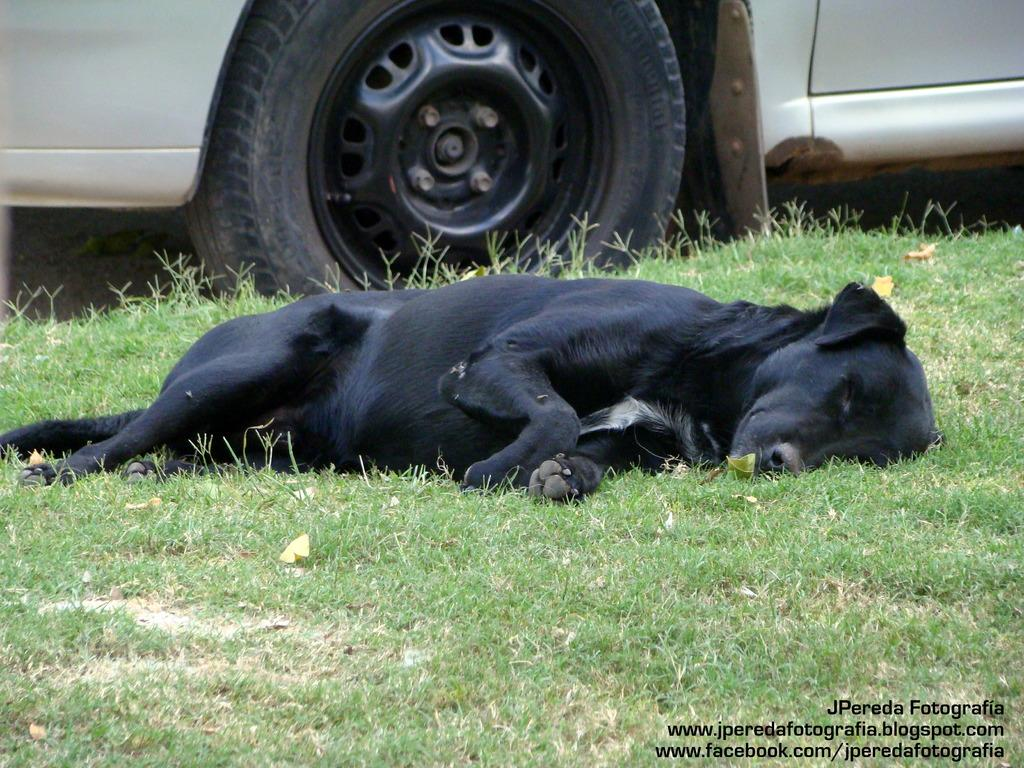What type of animal can be seen in the image? There is a dog in the image. What is the dog doing in the image? The dog is lying on the ground. What is the surface that the dog and car are standing on? The ground is covered with grass. What is the other main object in the image? There is a car in the image. What is the position of the car in the image? The car is standing on the ground. Can you see a vase on the ground in the image? There is no vase present in the image. What type of approval is the dog seeking in the image? The dog is not seeking any approval in the image; it is simply lying on the ground. 